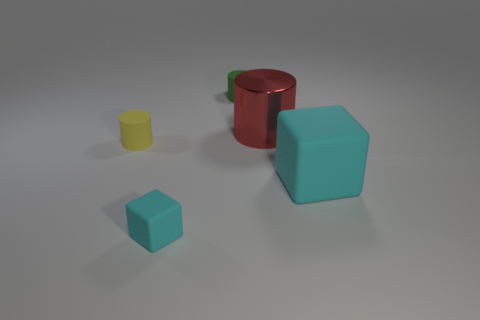Subtract all metallic cylinders. How many cylinders are left? 2 Subtract 1 cylinders. How many cylinders are left? 2 Add 1 tiny yellow cylinders. How many objects exist? 6 Subtract all blue cylinders. Subtract all cyan balls. How many cylinders are left? 3 Subtract all cylinders. How many objects are left? 2 Add 2 matte cubes. How many matte cubes are left? 4 Add 4 matte objects. How many matte objects exist? 8 Subtract 0 purple balls. How many objects are left? 5 Subtract all big blue spheres. Subtract all matte blocks. How many objects are left? 3 